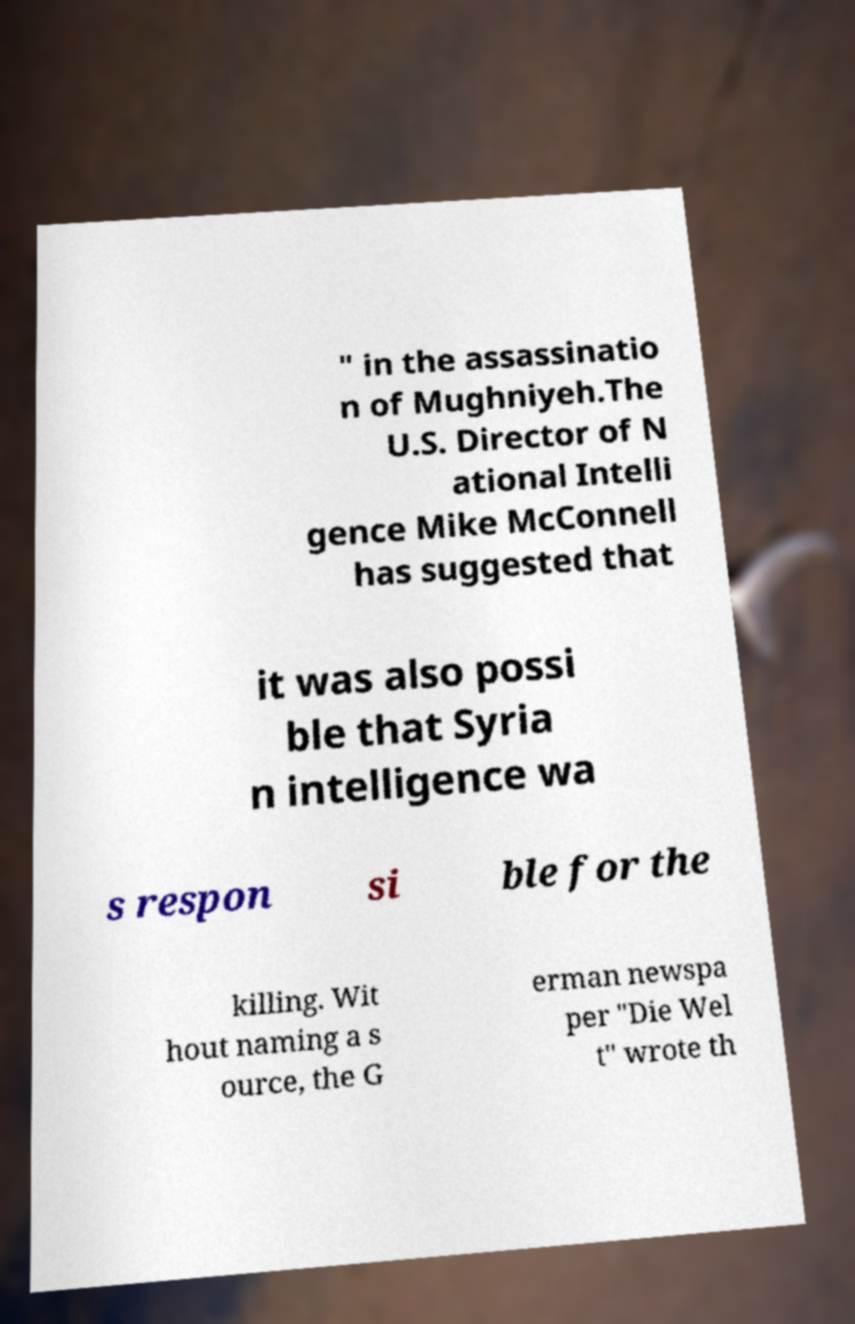Please identify and transcribe the text found in this image. " in the assassinatio n of Mughniyeh.The U.S. Director of N ational Intelli gence Mike McConnell has suggested that it was also possi ble that Syria n intelligence wa s respon si ble for the killing. Wit hout naming a s ource, the G erman newspa per "Die Wel t" wrote th 